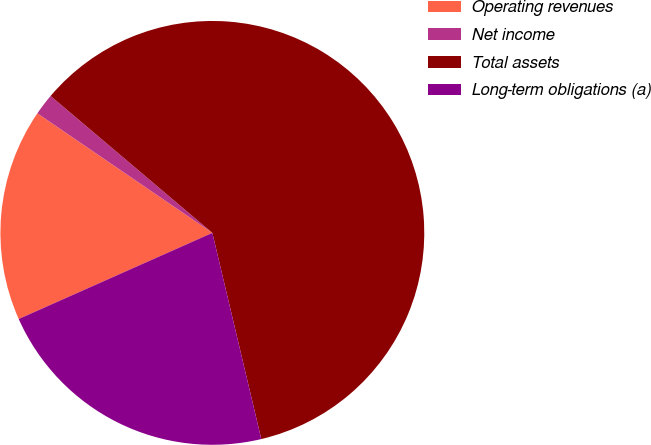Convert chart to OTSL. <chart><loc_0><loc_0><loc_500><loc_500><pie_chart><fcel>Operating revenues<fcel>Net income<fcel>Total assets<fcel>Long-term obligations (a)<nl><fcel>16.2%<fcel>1.64%<fcel>60.11%<fcel>22.05%<nl></chart> 